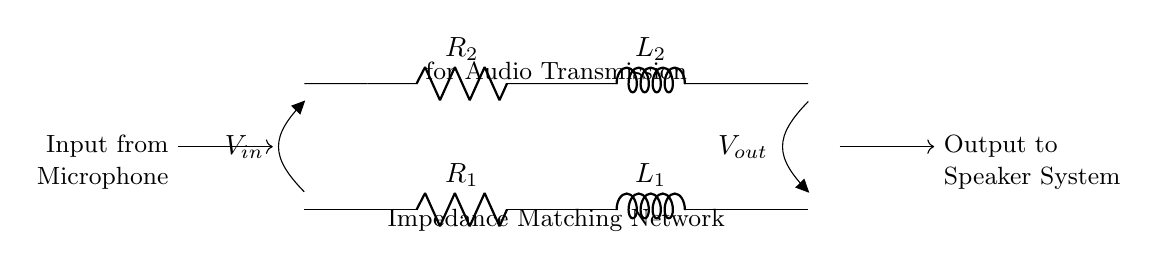What are the components of the circuit? The circuit contains two resistors and two inductors arranged in series, specifically labeled R1, L1, R2, and L2.
Answer: Resistors and inductors What is the purpose of this circuit? The circuit serves as an impedance matching network to optimize audio transmission between a microphone and a speaker system.
Answer: Impedance matching What is the input voltage represented in the circuit? The input voltage is denoted by the label V-in, indicating the voltage at the input point connected to the microphone in this circuit.
Answer: V-in What type of circuit configuration is used here? The circuit is configured as a series network of resistors and inductors which is typical for resonance and impedance matching applications.
Answer: Series circuit How many inductors are present in this circuit? There are two inductors in the circuit, indicated by L1 and L2, positioned between the corresponding resistors.
Answer: Two Explain the role of R1 and R2 in this network. R1 and R2 act as resistive loads that together with L1 and L2 adjust the impedance match to improve signal strength and clarity in audio transmission.
Answer: Adjust impedance What do L1 and L2 specifically contribute to the function of this circuit? L1 and L2 provide inductive reactance, which, when combined with the resistances of R1 and R2, helps achieve resonance at the desired frequency for effective audio signal transmission.
Answer: Inductive reactance 